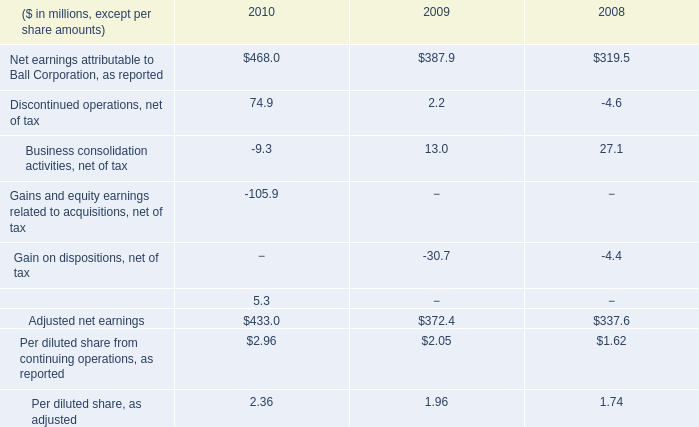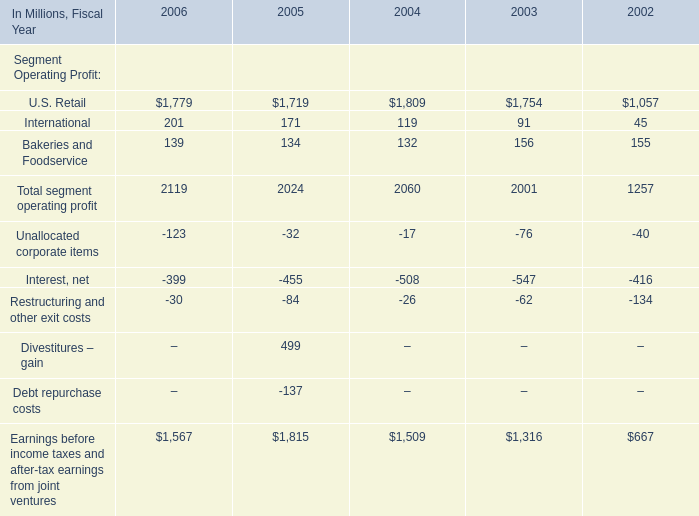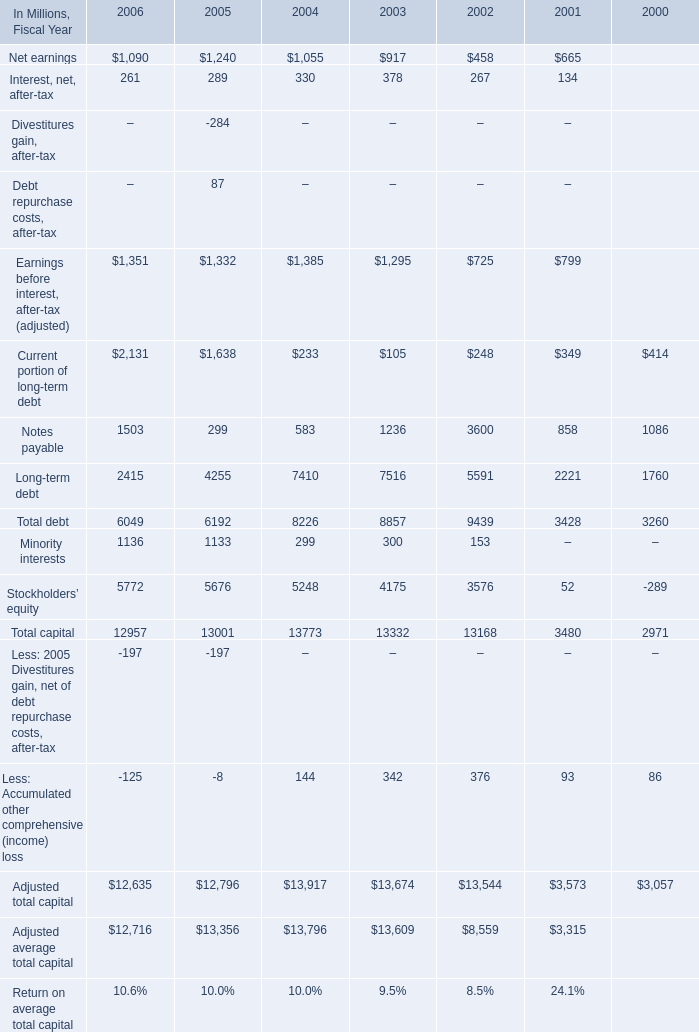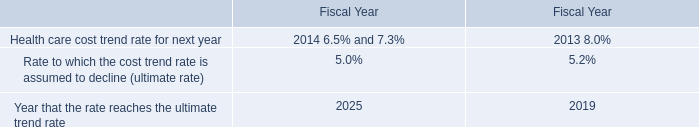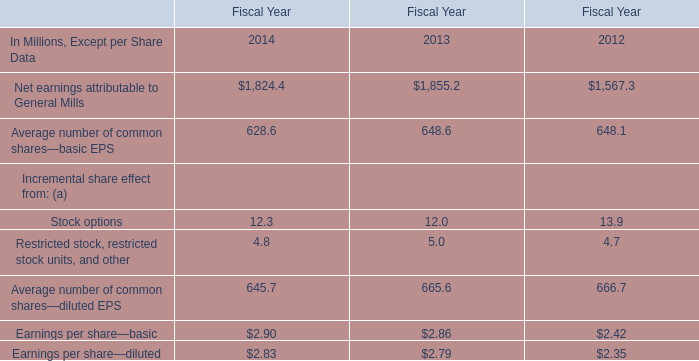what was the percentage change in per diluted share earnings as adjusted from 2008 to 2009? 
Computations: ((1.96 - 1.74) / 1.74)
Answer: 0.12644. 